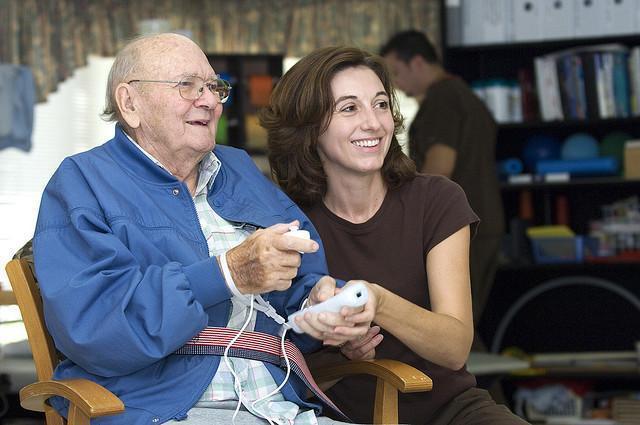How many chairs are in the photo?
Give a very brief answer. 2. How many people are there?
Give a very brief answer. 3. How many white dogs are there?
Give a very brief answer. 0. 